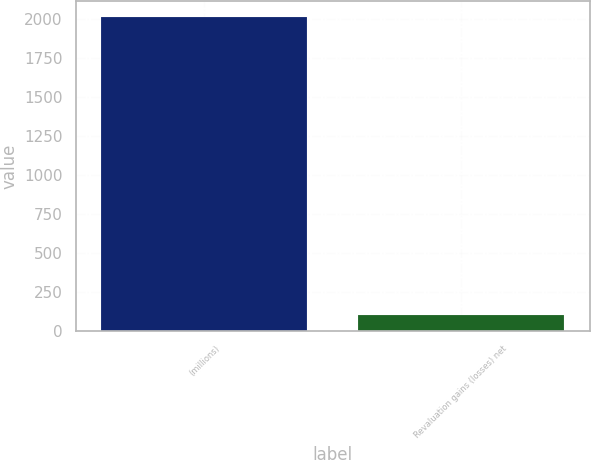Convert chart to OTSL. <chart><loc_0><loc_0><loc_500><loc_500><bar_chart><fcel>(millions)<fcel>Revaluation gains (losses) net<nl><fcel>2015<fcel>101.3<nl></chart> 